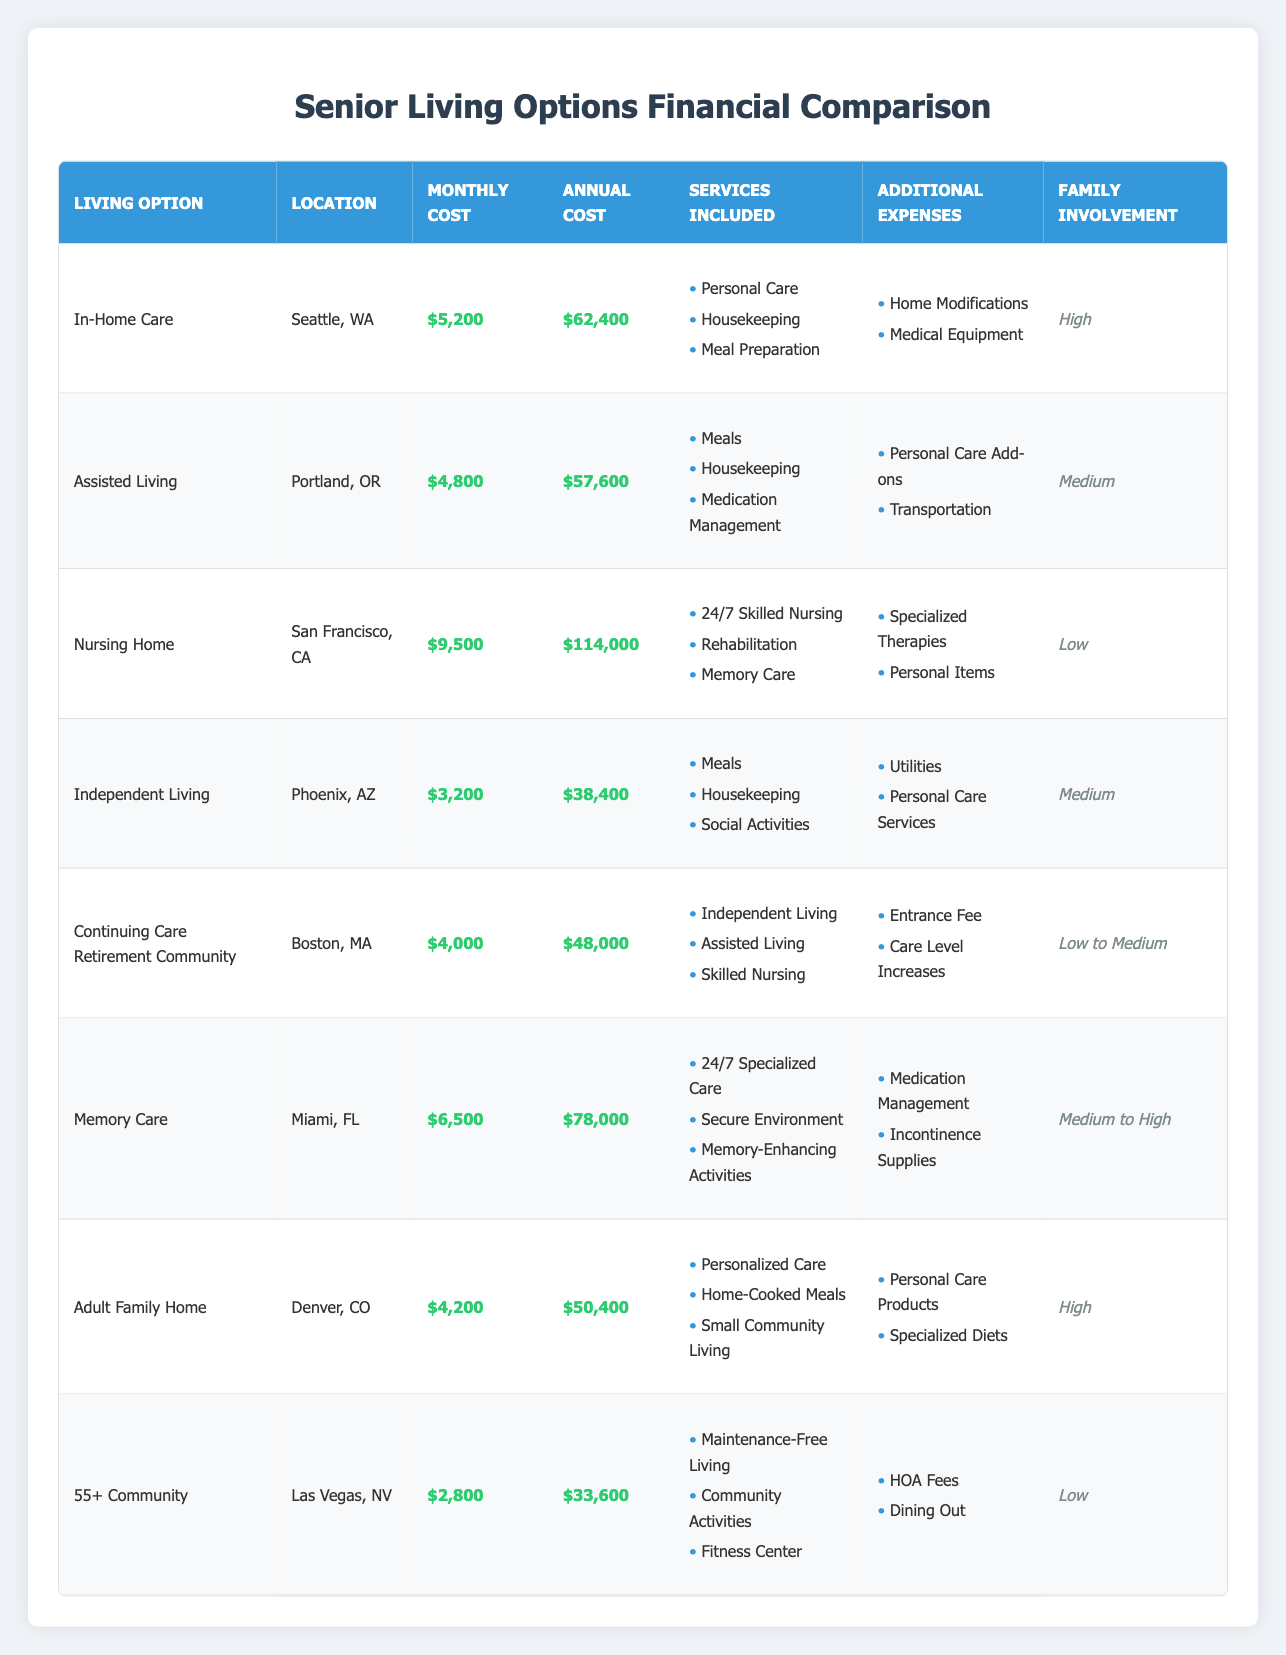What is the monthly cost for Assisted Living in Portland, OR? The table lists Assisted Living in Portland, OR with a monthly cost entry of $4,800.
Answer: $4,800 Which senior living option has the highest annual cost? To find the highest annual cost, compare the Annual Cost column entries: $62,400 for In-Home Care, $57,600 for Assisted Living, $114,000 for Nursing Home, $38,400 for Independent Living, $48,000 for Continuing Care Retirement Community, $78,000 for Memory Care, $50,400 for Adult Family Home, and $33,600 for 55+ Community. The highest value is $114,000 for Nursing Home.
Answer: Nursing Home Are families highly involved in Independent Living? According to the table, the Family Involvement level for Independent Living is marked as Medium, which indicates that family involvement is not categorized as High.
Answer: No What is the combined monthly cost of all the senior living options? First, sum the Monthly Cost entries: $5,200 (In-Home Care) + $4,800 (Assisted Living) + $9,500 (Nursing Home) + $3,200 (Independent Living) + $4,000 (Continuing Care Retirement Community) + $6,500 (Memory Care) + $4,200 (Adult Family Home) + $2,800 (55+ Community). The total equals $40,200.
Answer: $40,200 Is Memory Care available in Miami at a lower annual cost than In-Home Care in Seattle? Compare the Annual Cost of both options: Memory Care in Miami is $78,000 while In-Home Care in Seattle is $62,400. Since $78,000 is greater than $62,400, Memory Care is not available at a lower cost.
Answer: No What is the average monthly cost of Living Options that require high family involvement? Identify the options with High family involvement: In-Home Care and Adult Family Home, with monthly costs of $5,200 and $4,200 respectively. Then, calculate the average: (5,200 + 4,200) / 2 = $4,700.
Answer: $4,700 What additional expenses do Continuing Care Retirement Communities have? The table indicates that Continuing Care Retirement Communities include an Entrance Fee and Care Level Increases as additional expenses.
Answer: Entrance Fee and Care Level Increases Which living option includes 24/7 Skilled Nursing as a service? The Nursing Home listed in San Francisco, CA includes 24/7 Skilled Nursing as one of its services.
Answer: Nursing Home How much more does Nursing Home cost annually compared to Independent Living? The annual cost for Nursing Home is $114,000, while for Independent Living it is $38,400. The difference is calculated as $114,000 - $38,400 = $75,600.
Answer: $75,600 